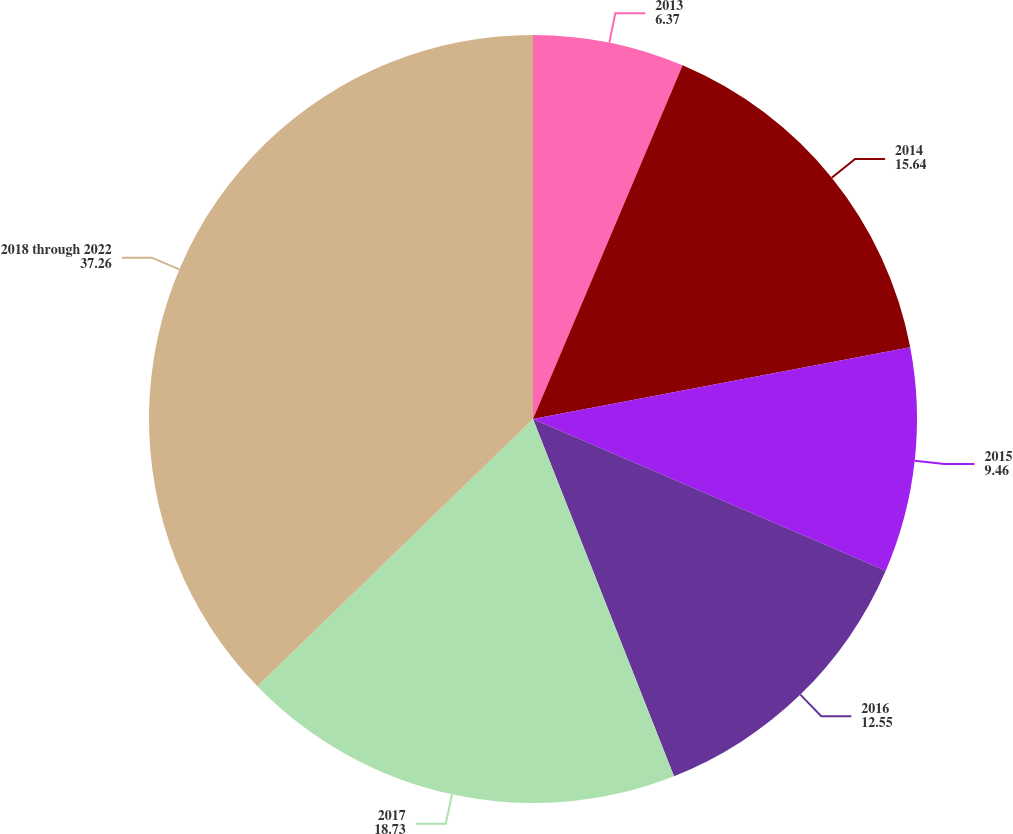Convert chart. <chart><loc_0><loc_0><loc_500><loc_500><pie_chart><fcel>2013<fcel>2014<fcel>2015<fcel>2016<fcel>2017<fcel>2018 through 2022<nl><fcel>6.37%<fcel>15.64%<fcel>9.46%<fcel>12.55%<fcel>18.73%<fcel>37.26%<nl></chart> 